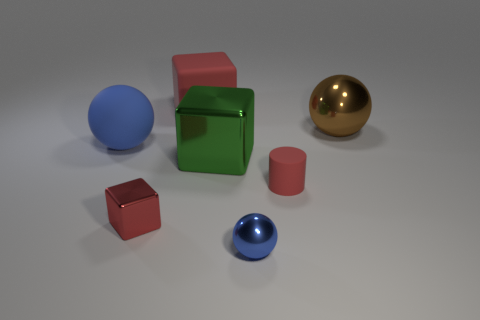Subtract all red cubes. How many were subtracted if there are1red cubes left? 1 Subtract all cyan cubes. Subtract all brown balls. How many cubes are left? 3 Add 2 tiny blue spheres. How many objects exist? 9 Subtract all balls. How many objects are left? 4 Subtract all large metallic cubes. Subtract all tiny things. How many objects are left? 3 Add 4 large green objects. How many large green objects are left? 5 Add 7 tiny red matte things. How many tiny red matte things exist? 8 Subtract 0 purple blocks. How many objects are left? 7 